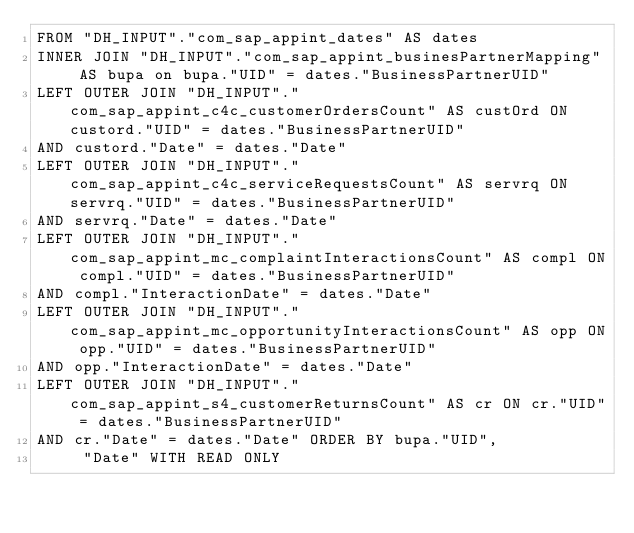<code> <loc_0><loc_0><loc_500><loc_500><_SQL_>FROM "DH_INPUT"."com_sap_appint_dates" AS dates 
INNER JOIN "DH_INPUT"."com_sap_appint_businesPartnerMapping" AS bupa on bupa."UID" = dates."BusinessPartnerUID" 
LEFT OUTER JOIN "DH_INPUT"."com_sap_appint_c4c_customerOrdersCount" AS custOrd ON custord."UID" = dates."BusinessPartnerUID" 
AND custord."Date" = dates."Date" 
LEFT OUTER JOIN "DH_INPUT"."com_sap_appint_c4c_serviceRequestsCount" AS servrq ON servrq."UID" = dates."BusinessPartnerUID" 
AND servrq."Date" = dates."Date" 
LEFT OUTER JOIN "DH_INPUT"."com_sap_appint_mc_complaintInteractionsCount" AS compl ON compl."UID" = dates."BusinessPartnerUID" 
AND compl."InteractionDate" = dates."Date" 
LEFT OUTER JOIN "DH_INPUT"."com_sap_appint_mc_opportunityInteractionsCount" AS opp ON opp."UID" = dates."BusinessPartnerUID" 
AND opp."InteractionDate" = dates."Date" 
LEFT OUTER JOIN "DH_INPUT"."com_sap_appint_s4_customerReturnsCount" AS cr ON cr."UID" = dates."BusinessPartnerUID" 
AND cr."Date" = dates."Date" ORDER BY bupa."UID",
	 "Date" WITH READ ONLY</code> 